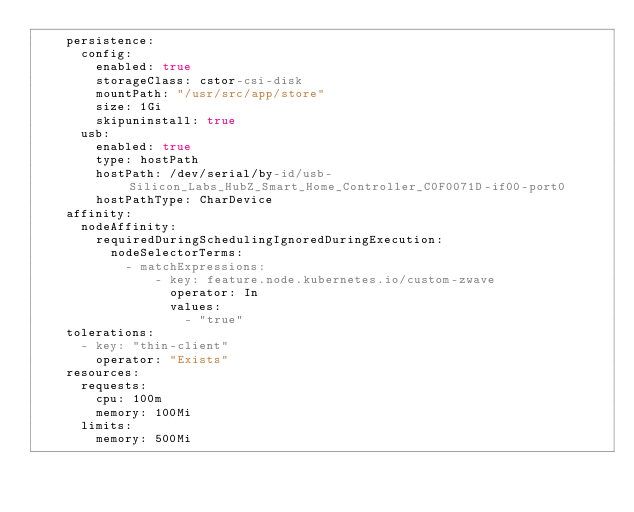Convert code to text. <code><loc_0><loc_0><loc_500><loc_500><_YAML_>    persistence:
      config:
        enabled: true
        storageClass: cstor-csi-disk
        mountPath: "/usr/src/app/store"
        size: 1Gi
        skipuninstall: true
      usb:
        enabled: true
        type: hostPath
        hostPath: /dev/serial/by-id/usb-Silicon_Labs_HubZ_Smart_Home_Controller_C0F0071D-if00-port0
        hostPathType: CharDevice
    affinity:
      nodeAffinity:
        requiredDuringSchedulingIgnoredDuringExecution:
          nodeSelectorTerms:
            - matchExpressions:
                - key: feature.node.kubernetes.io/custom-zwave
                  operator: In
                  values:
                    - "true"
    tolerations:
      - key: "thin-client"
        operator: "Exists"
    resources:
      requests:
        cpu: 100m
        memory: 100Mi
      limits:
        memory: 500Mi
</code> 